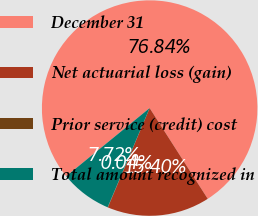Convert chart. <chart><loc_0><loc_0><loc_500><loc_500><pie_chart><fcel>December 31<fcel>Net actuarial loss (gain)<fcel>Prior service (credit) cost<fcel>Total amount recognized in<nl><fcel>76.84%<fcel>15.4%<fcel>0.04%<fcel>7.72%<nl></chart> 